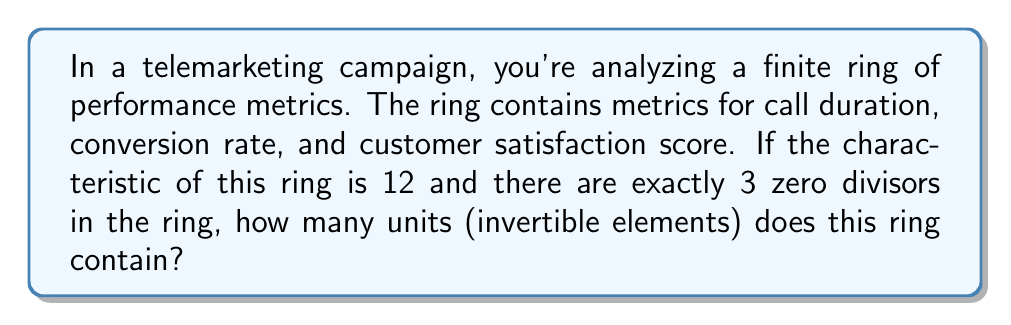Teach me how to tackle this problem. Let's approach this step-by-step:

1) In a finite ring $R$ with characteristic 12, the number of elements is a power of 12. Let's say $|R| = 12^n$ for some positive integer $n$.

2) Given that there are exactly 3 zero divisors in the ring, we can deduce that $|R| = 12$. This is because:
   - In a ring of 12 elements, the possible zero divisors are 2, 3, 4, 6, 8, 9, and 10.
   - The only way to have exactly 3 zero divisors is if $|R| = 12$, where the zero divisors are 0, 4, and 8.

3) In a finite ring, an element is either a unit or a zero divisor.

4) The number of elements in the ring is the sum of:
   - The number of units
   - The number of zero divisors
   - The zero element

5) Let $u$ be the number of units. Then:

   $$12 = u + 3 + 1$$

6) Solving for $u$:

   $$u = 12 - 4 = 8$$

Therefore, the ring contains 8 units.
Answer: 8 units 